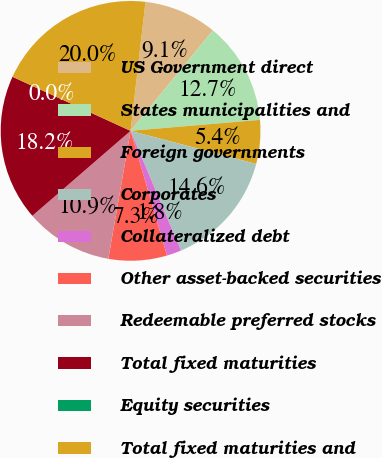Convert chart to OTSL. <chart><loc_0><loc_0><loc_500><loc_500><pie_chart><fcel>US Government direct<fcel>States municipalities and<fcel>Foreign governments<fcel>Corporates<fcel>Collateralized debt<fcel>Other asset-backed securities<fcel>Redeemable preferred stocks<fcel>Total fixed maturities<fcel>Equity securities<fcel>Total fixed maturities and<nl><fcel>9.09%<fcel>12.73%<fcel>5.45%<fcel>14.55%<fcel>1.82%<fcel>7.27%<fcel>10.91%<fcel>18.18%<fcel>0.0%<fcel>20.0%<nl></chart> 